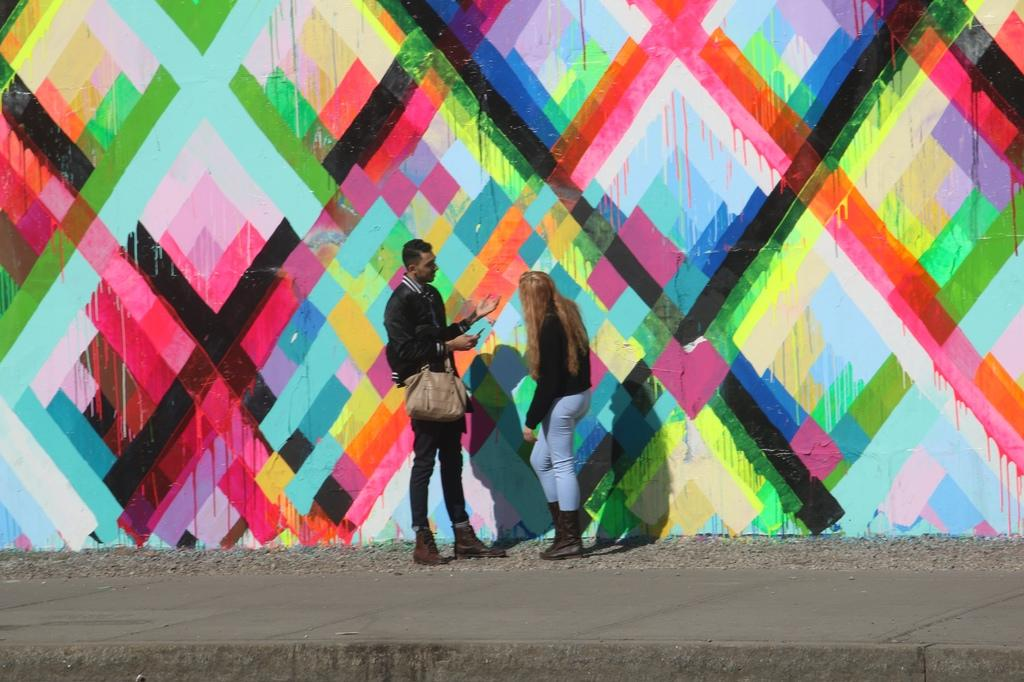How many people are in the image? There are two persons in the image. What is the background of the image? The persons are standing in front of a colorful wall. What object is located in the middle of the image? There is a bag in the middle of the image. What type of education can be seen being taught in the image? There is no education or teaching activity present in the image. How many people are in the crowd in the image? There is no crowd present in the image; only two persons are visible. 